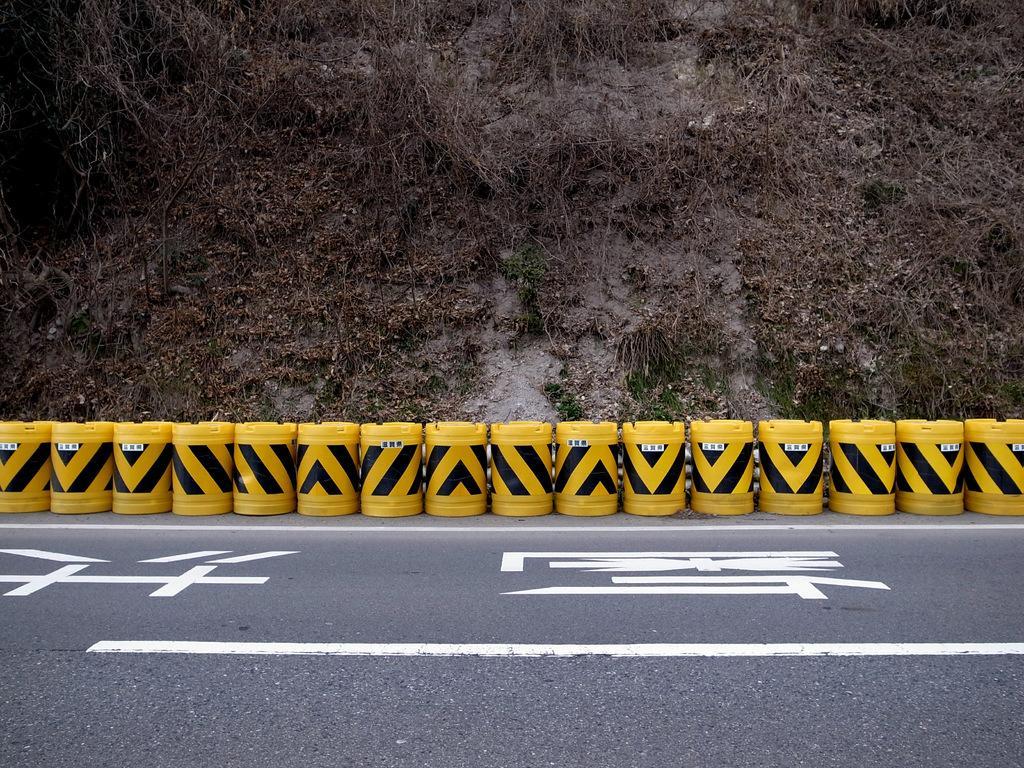Can you describe this image briefly? In this picture we can see a road. Behind the road, those are looking like traffic barrels. Behind the traffic barrels, it looks like a hill. 